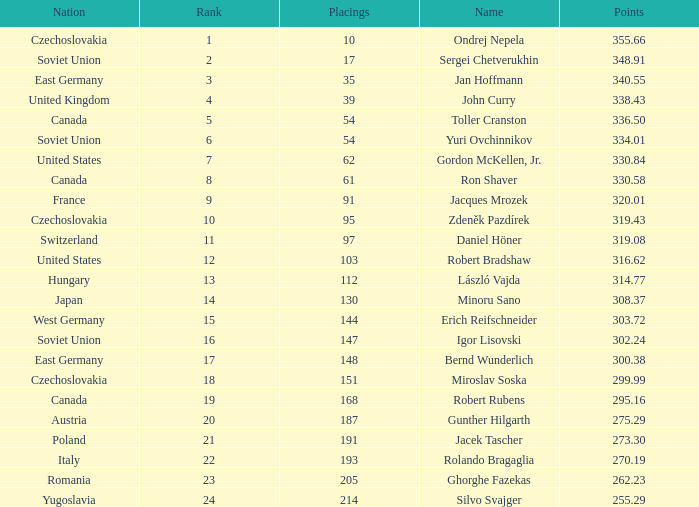Which Rank has a Name of john curry, and Points larger than 338.43? None. 